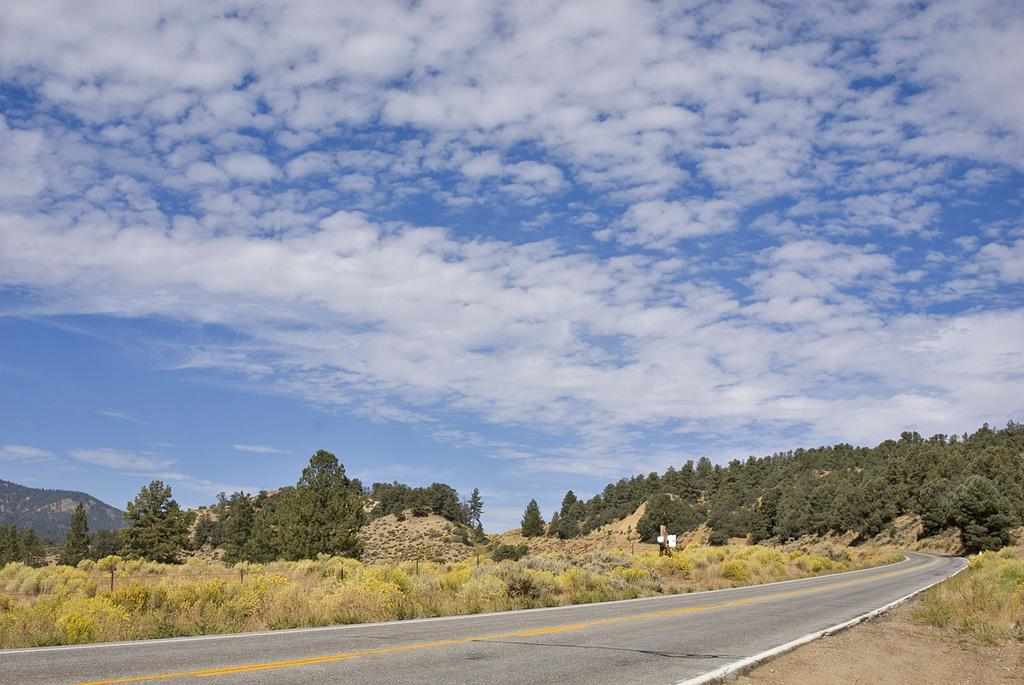What is located on the left side of the image? There is a road on the left side of the image. What can be seen on both sides of the road? There are plants on both sides of the road. What is visible in the background of the image? There are trees and mountains in the background of the image. What can be seen in the sky in the image? There are clouds visible in the sky. What language is spoken by the mountains in the image? The mountains do not speak a language, as they are inanimate objects. 